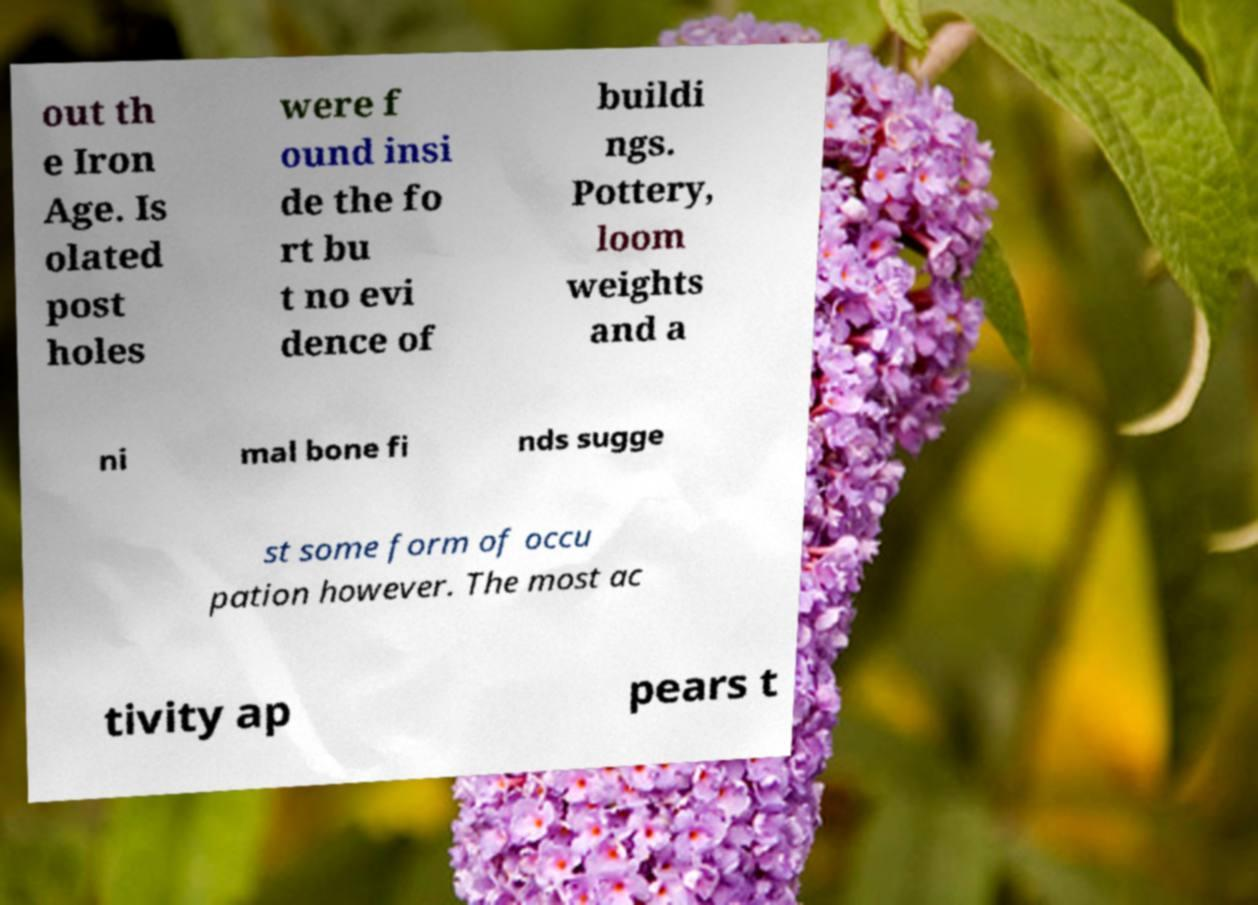Please identify and transcribe the text found in this image. out th e Iron Age. Is olated post holes were f ound insi de the fo rt bu t no evi dence of buildi ngs. Pottery, loom weights and a ni mal bone fi nds sugge st some form of occu pation however. The most ac tivity ap pears t 